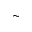Convert formula to latex. <formula><loc_0><loc_0><loc_500><loc_500>\sim</formula> 